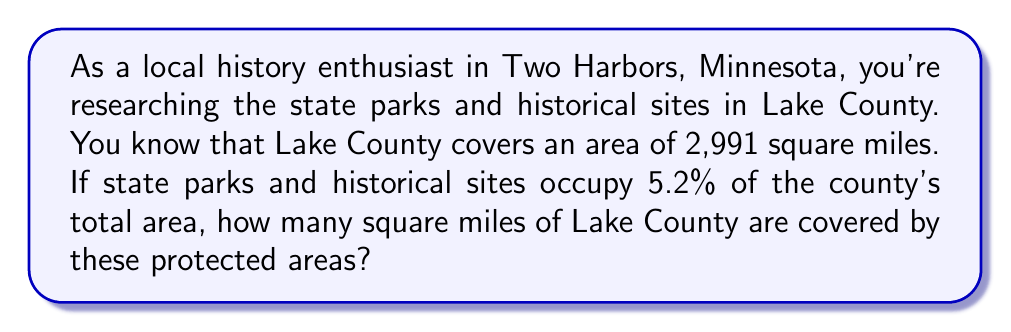Could you help me with this problem? To solve this problem, we need to calculate a percentage of the total area of Lake County. Let's break it down step-by-step:

1. Given information:
   - Total area of Lake County: 2,991 square miles
   - Percentage of area covered by state parks and historical sites: 5.2%

2. To find the area covered by state parks and historical sites, we need to calculate 5.2% of 2,991 square miles.

3. Convert the percentage to a decimal:
   $5.2\% = 5.2 \div 100 = 0.052$

4. Multiply the total area by the decimal form of the percentage:
   $$\text{Area of state parks and historical sites} = 2,991 \times 0.052$$

5. Perform the calculation:
   $$2,991 \times 0.052 = 155.532$$

6. Round to a reasonable number of decimal places (in this case, to the nearest tenth of a square mile):
   $$155.532 \approx 155.5 \text{ square miles}$$

Therefore, state parks and historical sites cover approximately 155.5 square miles of Lake County.
Answer: $155.5 \text{ square miles}$ 